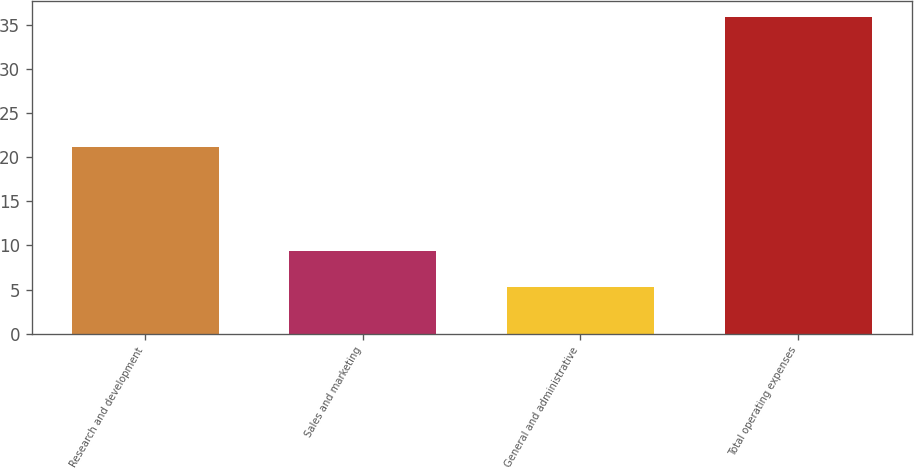Convert chart. <chart><loc_0><loc_0><loc_500><loc_500><bar_chart><fcel>Research and development<fcel>Sales and marketing<fcel>General and administrative<fcel>Total operating expenses<nl><fcel>21.2<fcel>9.4<fcel>5.3<fcel>35.9<nl></chart> 